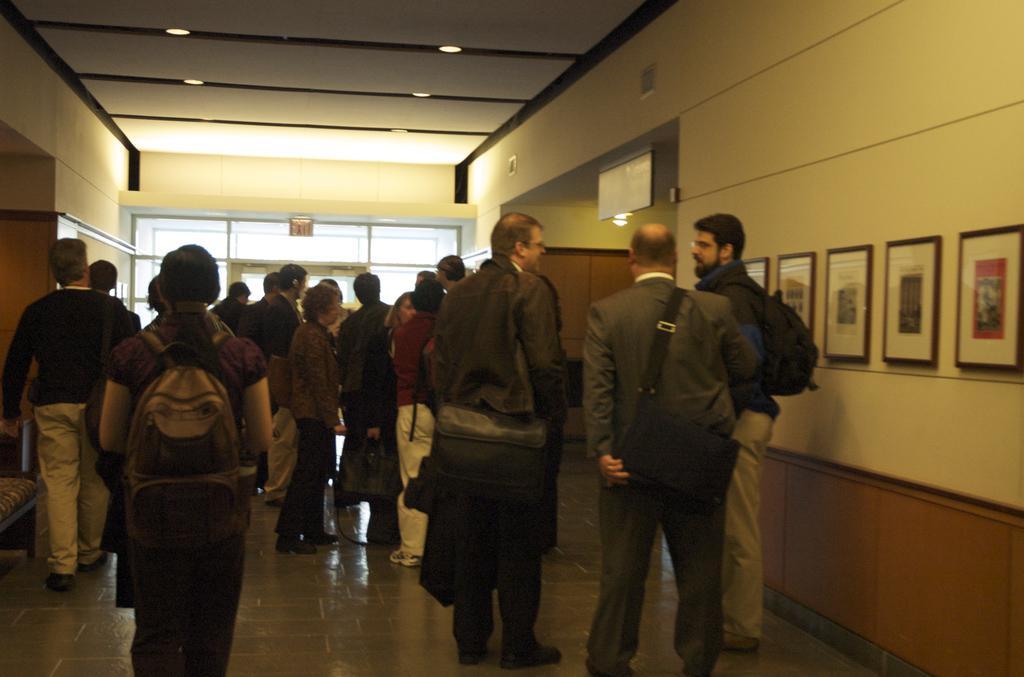Please provide a concise description of this image. In this image I can see people standing in a building. There are photo frames on a wall, on the right. There are lights at the top and a glass door at the back. 